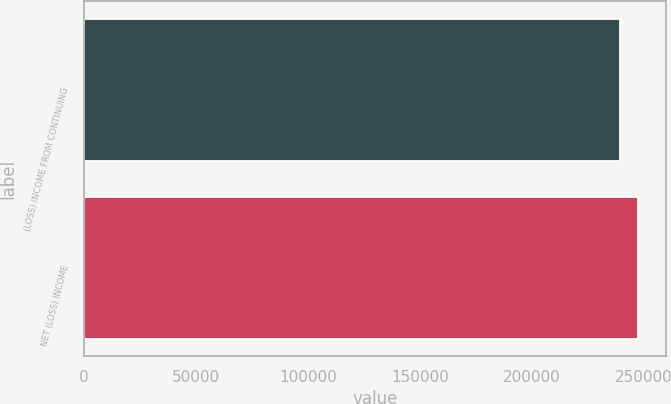Convert chart. <chart><loc_0><loc_0><loc_500><loc_500><bar_chart><fcel>(LOSS) INCOME FROM CONTINUING<fcel>NET (LOSS) INCOME<nl><fcel>239242<fcel>247587<nl></chart> 